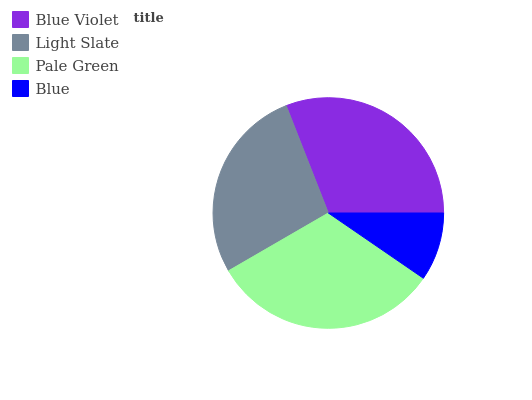Is Blue the minimum?
Answer yes or no. Yes. Is Pale Green the maximum?
Answer yes or no. Yes. Is Light Slate the minimum?
Answer yes or no. No. Is Light Slate the maximum?
Answer yes or no. No. Is Blue Violet greater than Light Slate?
Answer yes or no. Yes. Is Light Slate less than Blue Violet?
Answer yes or no. Yes. Is Light Slate greater than Blue Violet?
Answer yes or no. No. Is Blue Violet less than Light Slate?
Answer yes or no. No. Is Blue Violet the high median?
Answer yes or no. Yes. Is Light Slate the low median?
Answer yes or no. Yes. Is Light Slate the high median?
Answer yes or no. No. Is Blue Violet the low median?
Answer yes or no. No. 